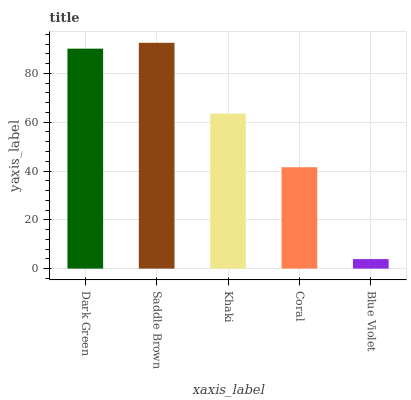Is Blue Violet the minimum?
Answer yes or no. Yes. Is Saddle Brown the maximum?
Answer yes or no. Yes. Is Khaki the minimum?
Answer yes or no. No. Is Khaki the maximum?
Answer yes or no. No. Is Saddle Brown greater than Khaki?
Answer yes or no. Yes. Is Khaki less than Saddle Brown?
Answer yes or no. Yes. Is Khaki greater than Saddle Brown?
Answer yes or no. No. Is Saddle Brown less than Khaki?
Answer yes or no. No. Is Khaki the high median?
Answer yes or no. Yes. Is Khaki the low median?
Answer yes or no. Yes. Is Coral the high median?
Answer yes or no. No. Is Dark Green the low median?
Answer yes or no. No. 